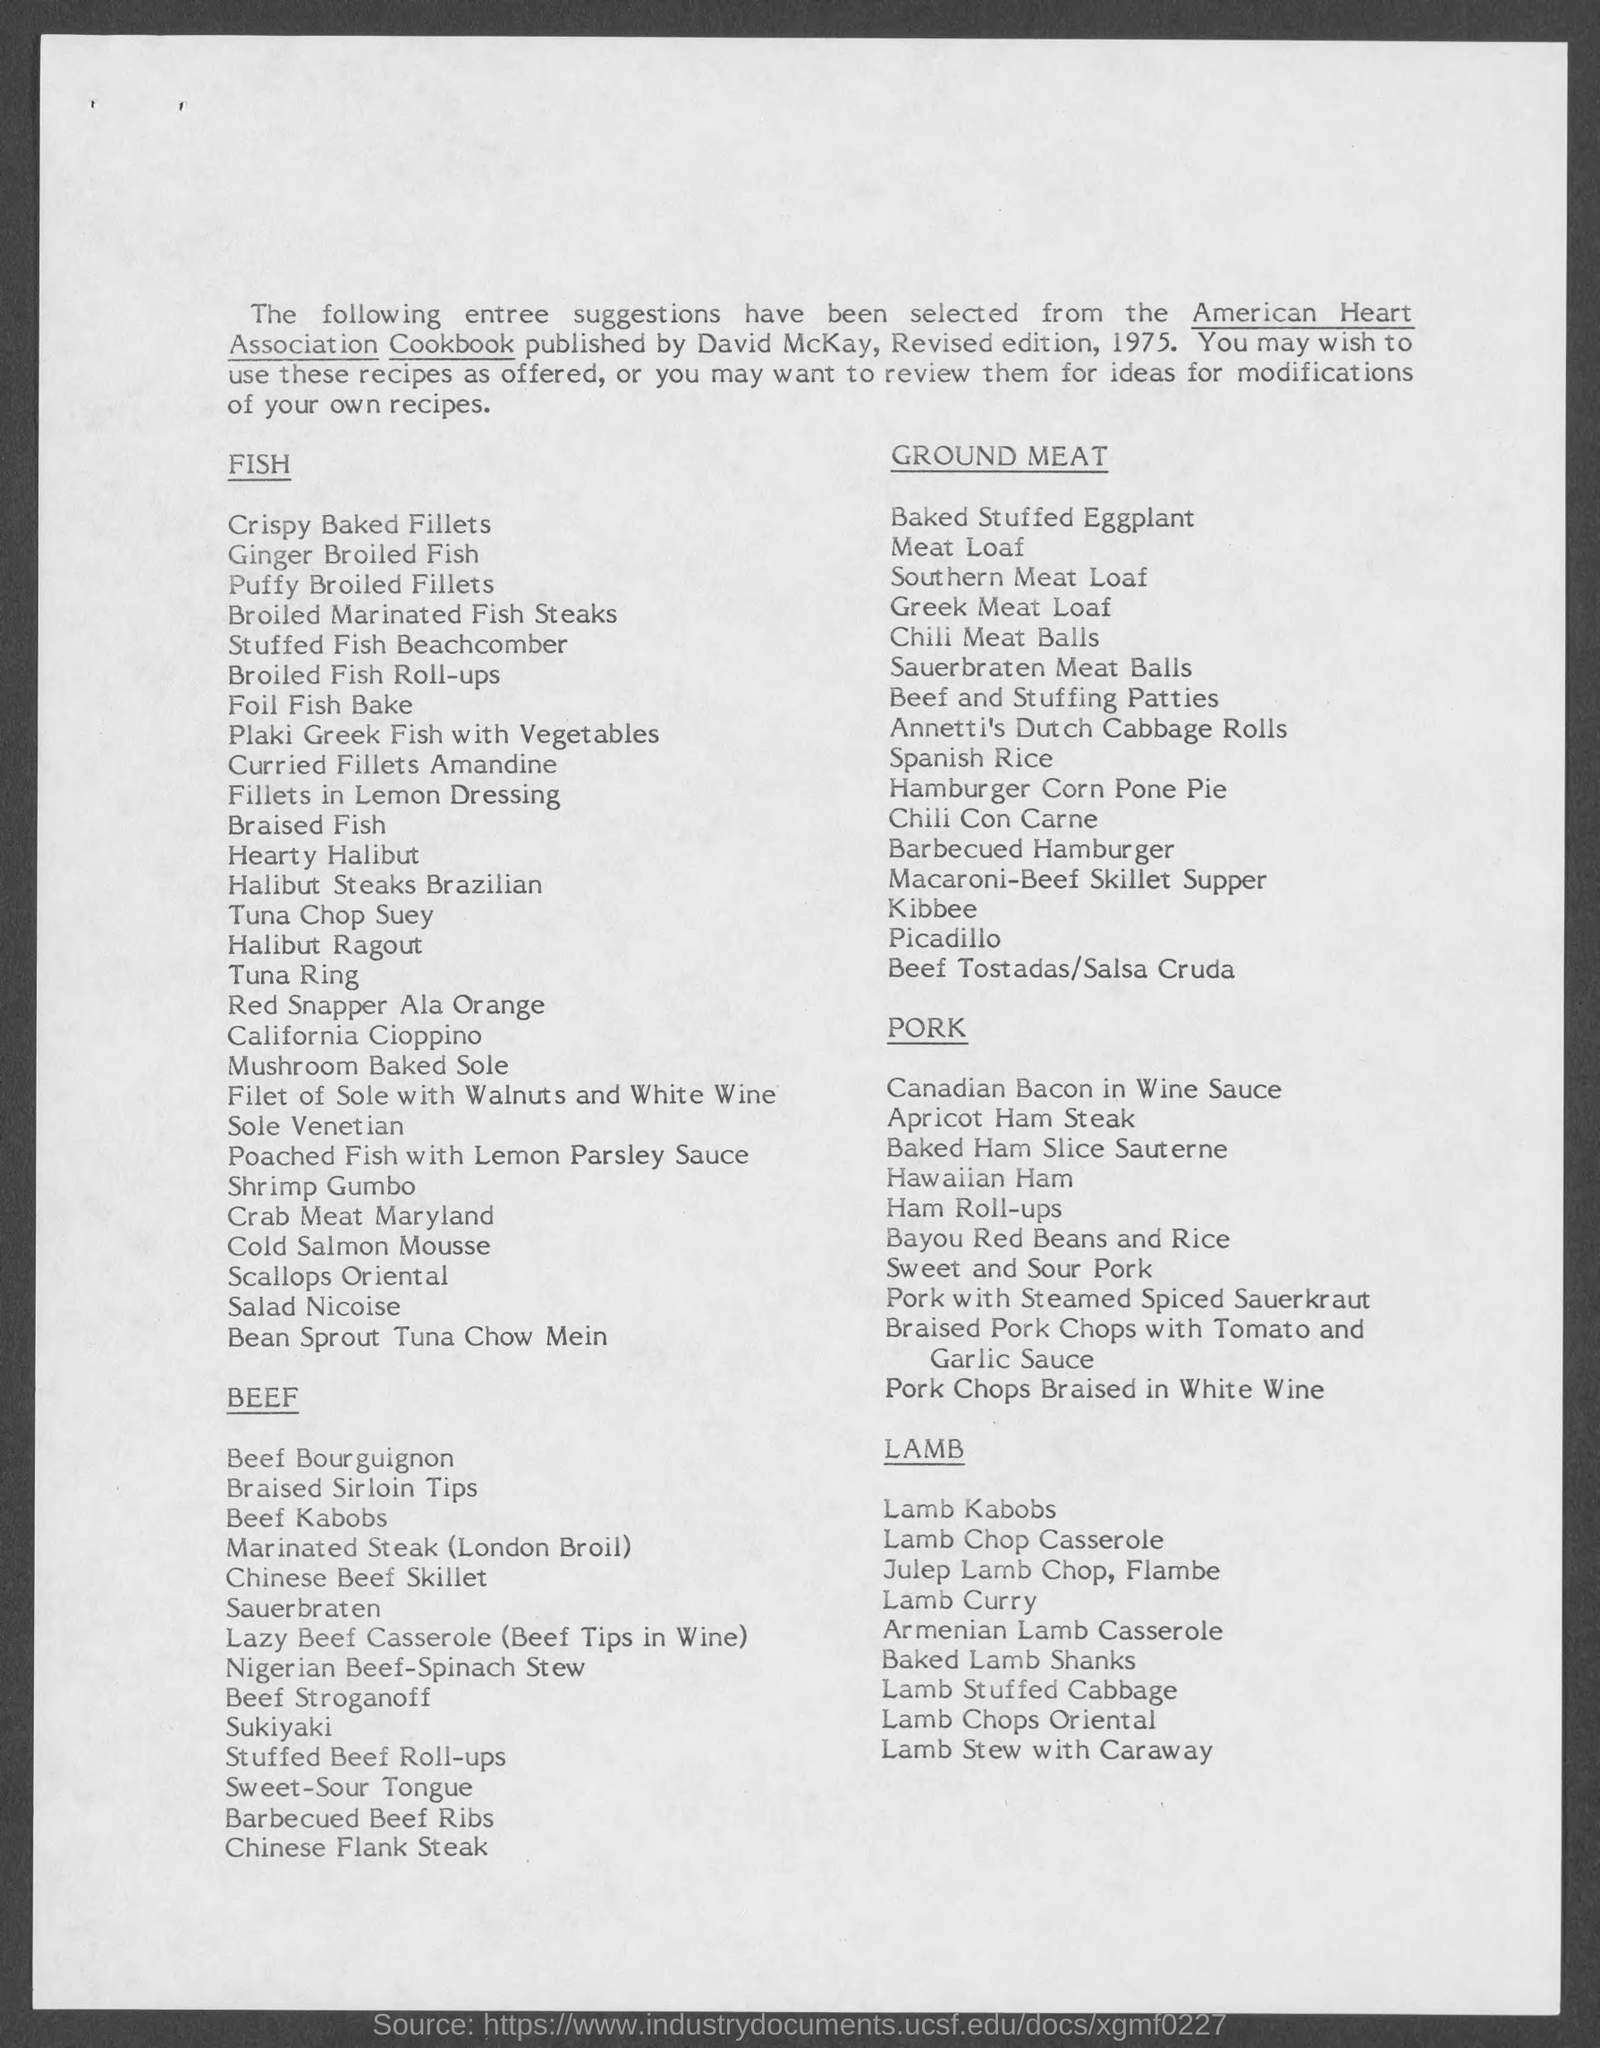Point out several critical features in this image. The American Heart Association Cookbook was published by David McKay. 